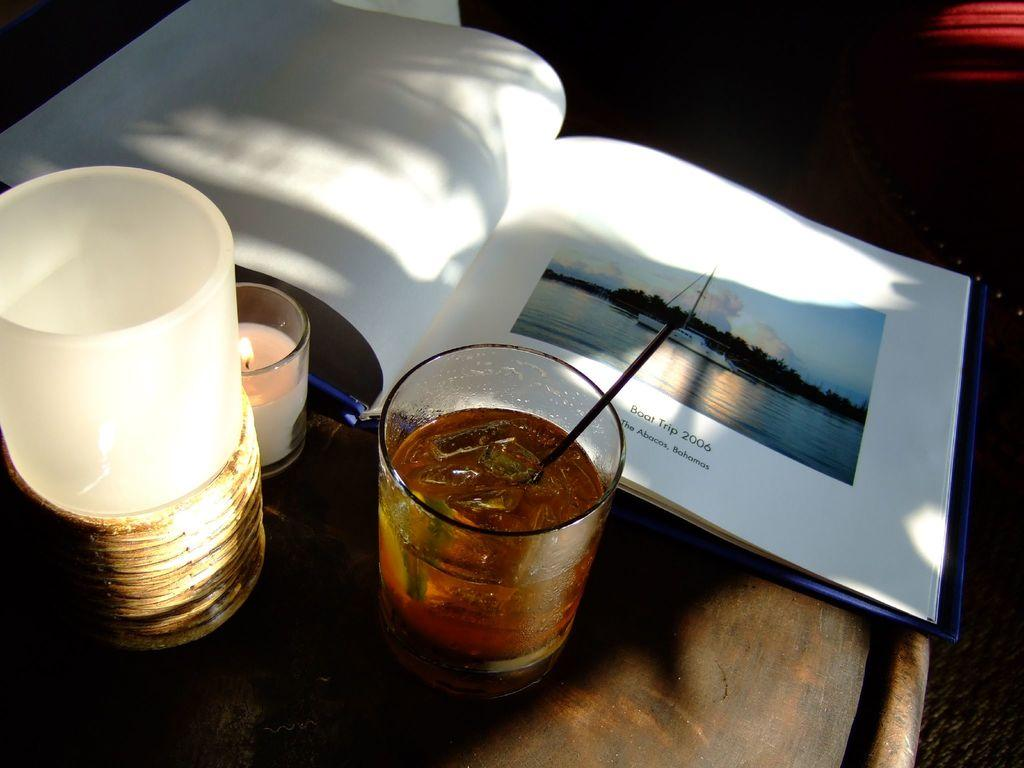<image>
Write a terse but informative summary of the picture. An album opened up to a page for a boat trip that was taken to the Bahamas is on a table next to a drink and a candle. 